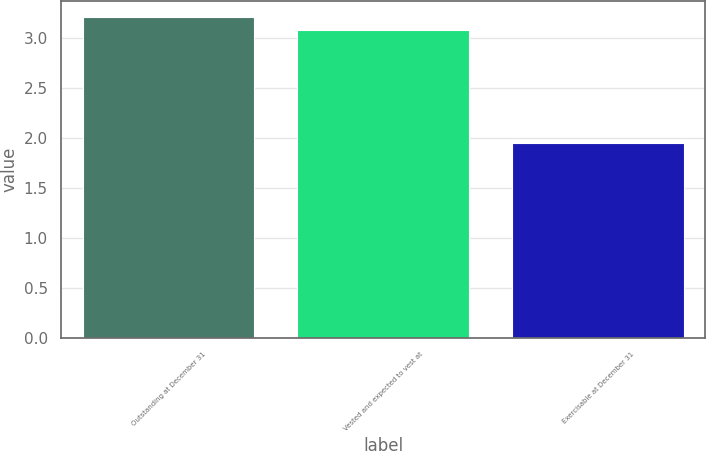<chart> <loc_0><loc_0><loc_500><loc_500><bar_chart><fcel>Outstanding at December 31<fcel>Vested and expected to vest at<fcel>Exercisable at December 31<nl><fcel>3.21<fcel>3.08<fcel>1.95<nl></chart> 